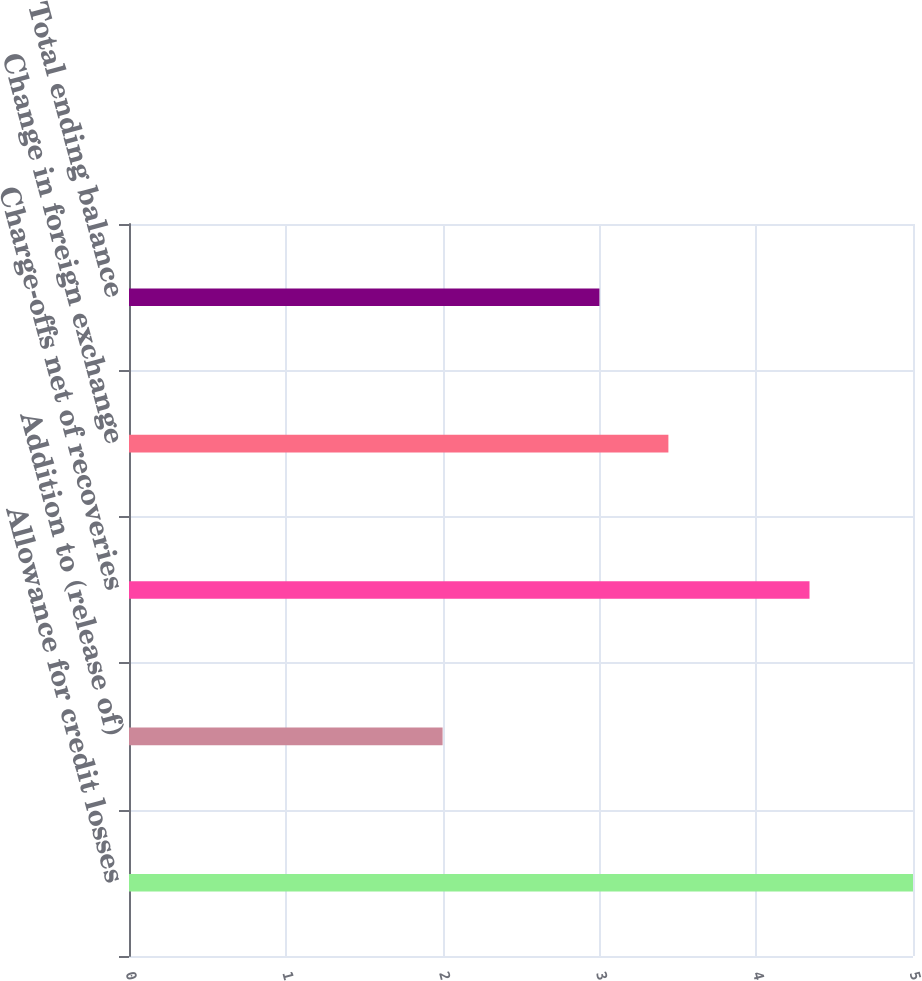Convert chart to OTSL. <chart><loc_0><loc_0><loc_500><loc_500><bar_chart><fcel>Allowance for credit losses<fcel>Addition to (release of)<fcel>Charge-offs net of recoveries<fcel>Change in foreign exchange<fcel>Total ending balance<nl><fcel>5<fcel>2<fcel>4.34<fcel>3.44<fcel>3<nl></chart> 